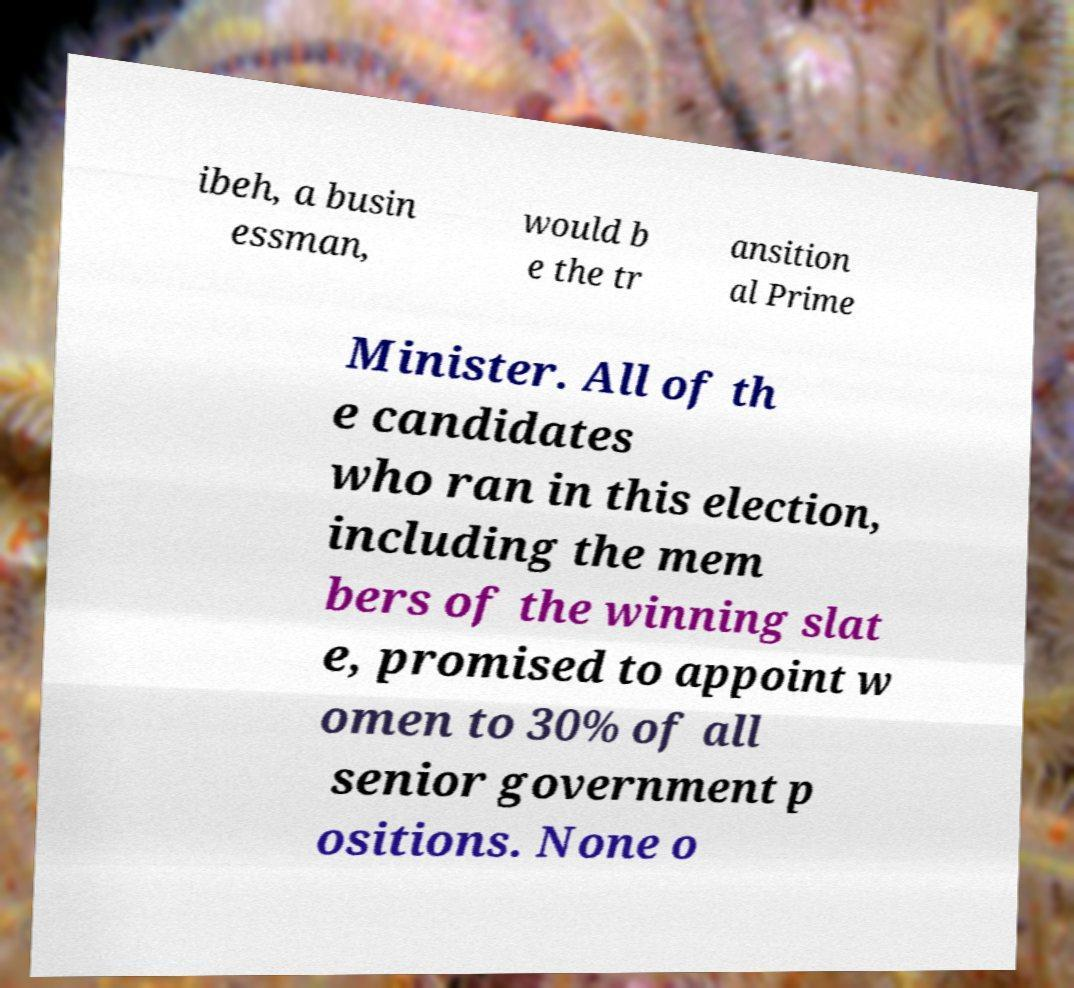Please identify and transcribe the text found in this image. ibeh, a busin essman, would b e the tr ansition al Prime Minister. All of th e candidates who ran in this election, including the mem bers of the winning slat e, promised to appoint w omen to 30% of all senior government p ositions. None o 